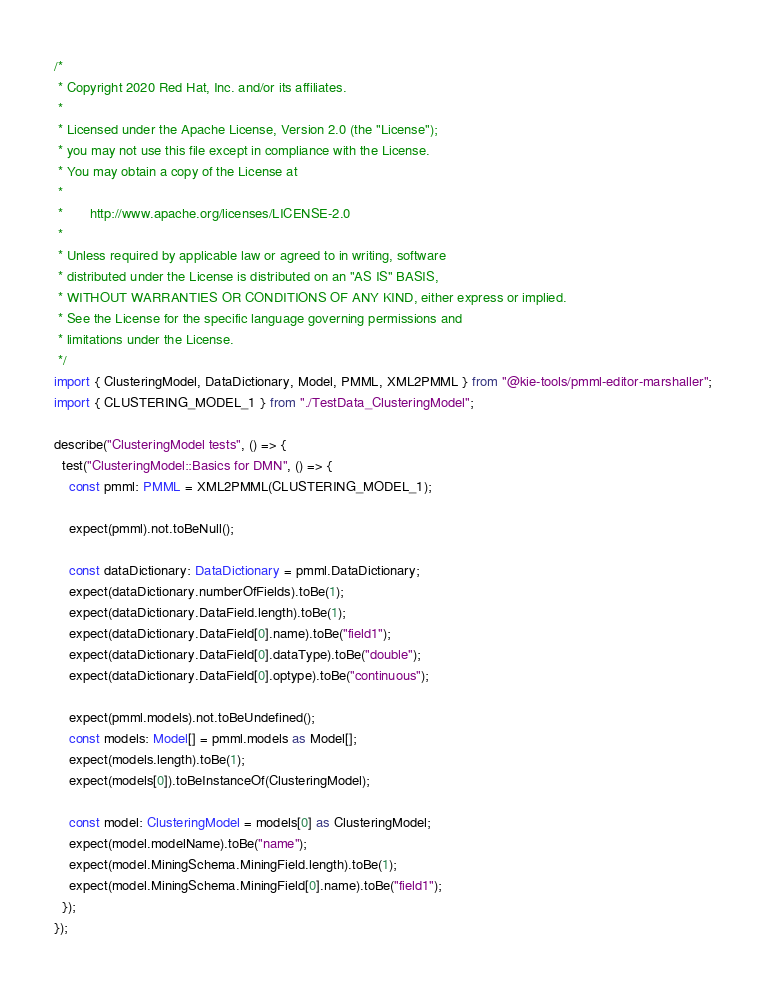Convert code to text. <code><loc_0><loc_0><loc_500><loc_500><_TypeScript_>/*
 * Copyright 2020 Red Hat, Inc. and/or its affiliates.
 *
 * Licensed under the Apache License, Version 2.0 (the "License");
 * you may not use this file except in compliance with the License.
 * You may obtain a copy of the License at
 *
 *       http://www.apache.org/licenses/LICENSE-2.0
 *
 * Unless required by applicable law or agreed to in writing, software
 * distributed under the License is distributed on an "AS IS" BASIS,
 * WITHOUT WARRANTIES OR CONDITIONS OF ANY KIND, either express or implied.
 * See the License for the specific language governing permissions and
 * limitations under the License.
 */
import { ClusteringModel, DataDictionary, Model, PMML, XML2PMML } from "@kie-tools/pmml-editor-marshaller";
import { CLUSTERING_MODEL_1 } from "./TestData_ClusteringModel";

describe("ClusteringModel tests", () => {
  test("ClusteringModel::Basics for DMN", () => {
    const pmml: PMML = XML2PMML(CLUSTERING_MODEL_1);

    expect(pmml).not.toBeNull();

    const dataDictionary: DataDictionary = pmml.DataDictionary;
    expect(dataDictionary.numberOfFields).toBe(1);
    expect(dataDictionary.DataField.length).toBe(1);
    expect(dataDictionary.DataField[0].name).toBe("field1");
    expect(dataDictionary.DataField[0].dataType).toBe("double");
    expect(dataDictionary.DataField[0].optype).toBe("continuous");

    expect(pmml.models).not.toBeUndefined();
    const models: Model[] = pmml.models as Model[];
    expect(models.length).toBe(1);
    expect(models[0]).toBeInstanceOf(ClusteringModel);

    const model: ClusteringModel = models[0] as ClusteringModel;
    expect(model.modelName).toBe("name");
    expect(model.MiningSchema.MiningField.length).toBe(1);
    expect(model.MiningSchema.MiningField[0].name).toBe("field1");
  });
});
</code> 